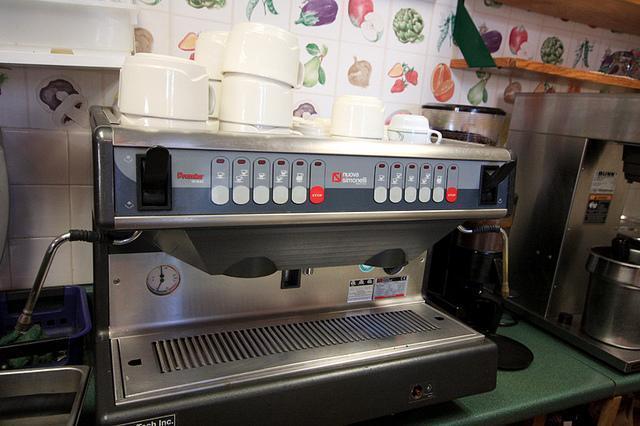How many cups can be seen?
Give a very brief answer. 3. How many bowls are in the picture?
Give a very brief answer. 2. How many people in the boats?
Give a very brief answer. 0. 